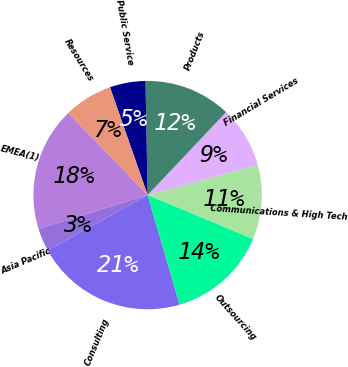<chart> <loc_0><loc_0><loc_500><loc_500><pie_chart><fcel>Communications & High Tech<fcel>Financial Services<fcel>Products<fcel>Public Service<fcel>Resources<fcel>EMEA(1)<fcel>Asia Pacific<fcel>Consulting<fcel>Outsourcing<nl><fcel>10.53%<fcel>8.7%<fcel>12.36%<fcel>5.05%<fcel>6.88%<fcel>17.58%<fcel>3.22%<fcel>21.5%<fcel>14.19%<nl></chart> 